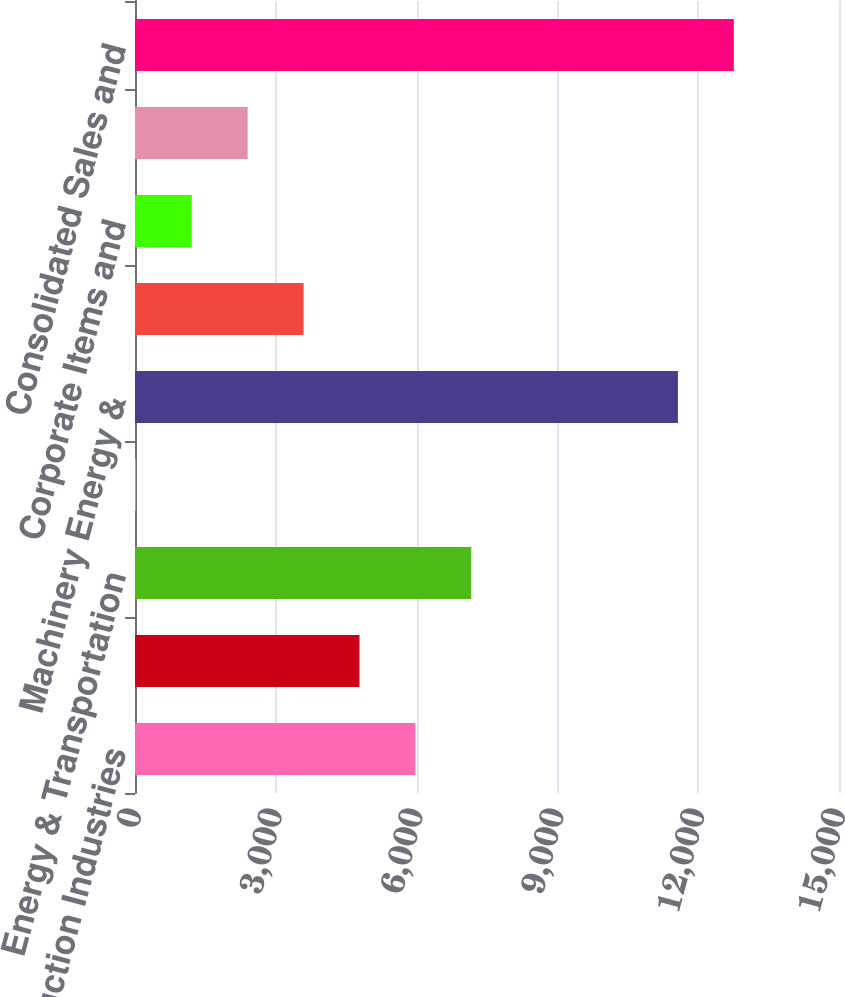<chart> <loc_0><loc_0><loc_500><loc_500><bar_chart><fcel>Construction Industries<fcel>Resource Industries<fcel>Energy & Transportation<fcel>All Other operating segments<fcel>Machinery Energy &<fcel>Financial Products Segment<fcel>Corporate Items and<fcel>Financial Products Revenues<fcel>Consolidated Sales and<nl><fcel>5973.5<fcel>4782.4<fcel>7164.6<fcel>18<fcel>11568<fcel>3591.3<fcel>1209.1<fcel>2400.2<fcel>12759.1<nl></chart> 